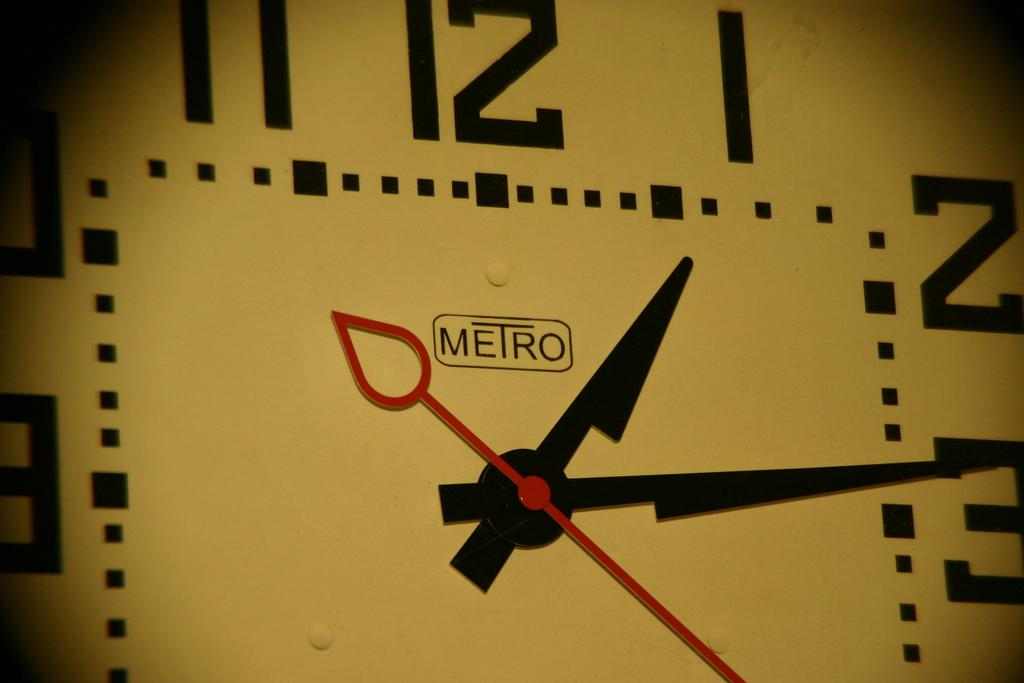Provide a one-sentence caption for the provided image. An extreme close up of a Metro clock showing the time at nearly 1:15. 